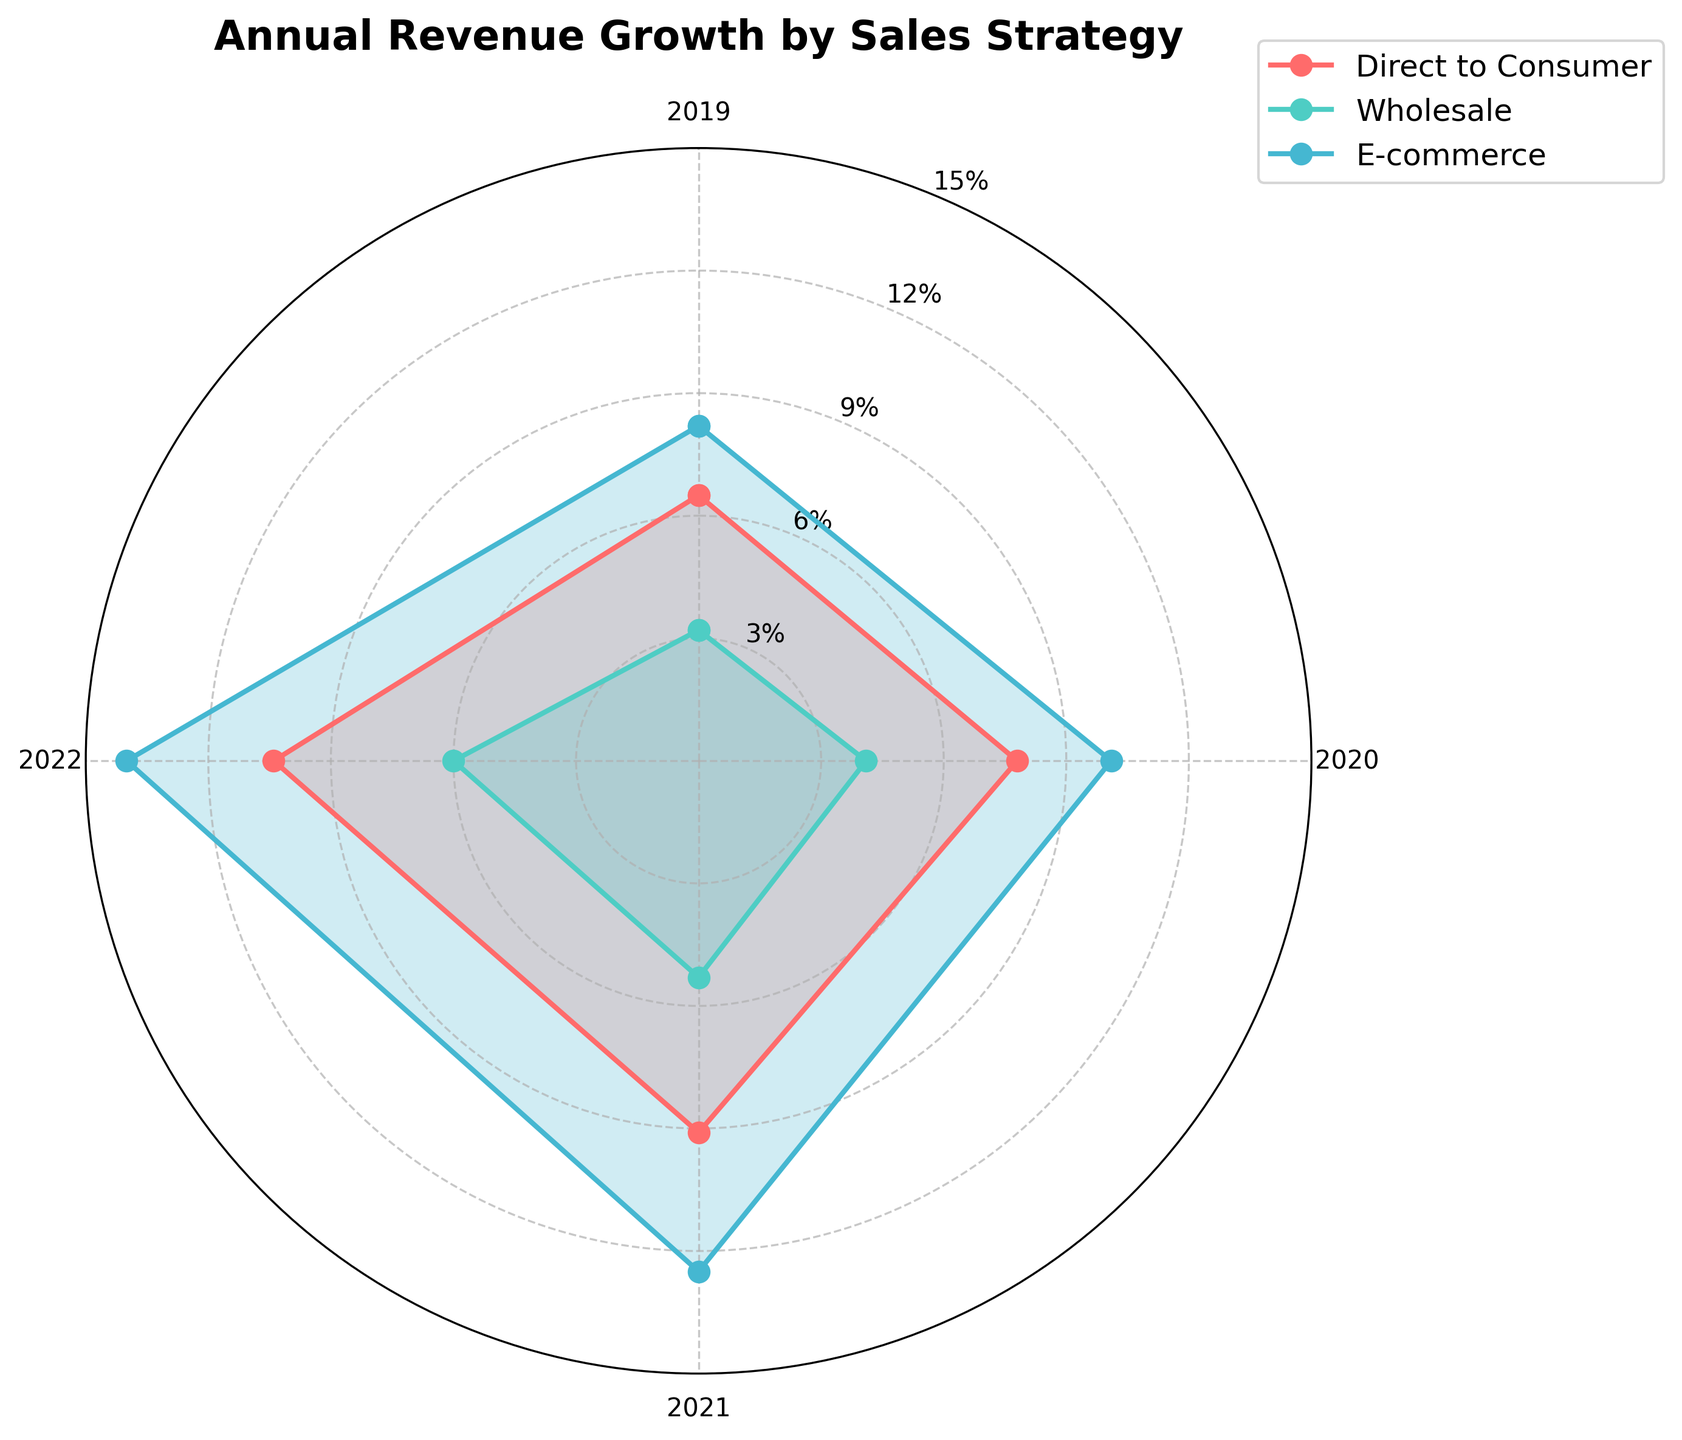What is the title of the figure? The title is seen at the top center of the radar chart.
Answer: Annual Revenue Growth by Sales Strategy What sales strategy had the highest revenue growth in 2022? By observing the chart, the strategy with the highest point/value for 2022 indicates the highest growth.
Answer: E-commerce Which year shows the lowest growth for the Wholesale strategy? The radar chart depicts the growth values for each year surrounding the center. The smallest value for the Wholesale line is the lowest growth year.
Answer: 2019 Which sales strategy shows the most consistent growth trend from 2019 to 2022? To determine consistency, look for the strategy with the most even and steady line across all years.
Answer: Direct to Consumer How much higher was the revenue growth for E-commerce compared to Wholesale in 2021? Find the values for both E-commerce and Wholesale in 2021 from the chart and calculate the difference.
Answer: 12.5% - 5.3% = 7.2% In which year did Direct to Consumer surpass 10% growth? Check the values for Direct to Consumer and identify which year first exceeds the 10% mark.
Answer: 2022 By how much did the revenue growth for Wholesale increase from 2019 to 2022? Calculate the difference between the values of Wholesale in 2022 and 2019.
Answer: 6.0% - 3.2% = 2.8% What is the average revenue growth for E-commerce from 2019 to 2022? Sum the annual growth values for E-commerce and divide by the number of years.
Answer: (8.2 + 10.1 + 12.5 + 14.0) / 4 = 11.2% Which sales strategy shows the steepest increase between any two consecutive years? Compare the slope (change in value) between the points for each strategy over consecutive years to find the steepest rise.
Answer: E-commerce 